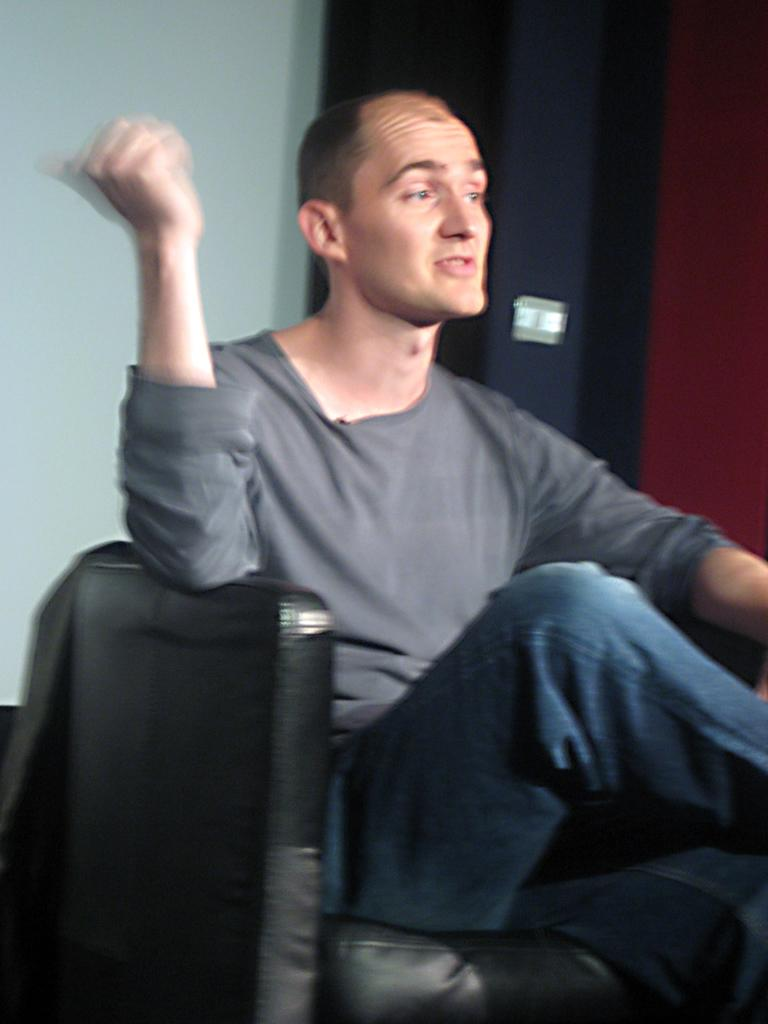What is the main subject of the image? There is a person in the image. What is the person doing in the image? The person is sitting on a chair. What can be seen behind the person? There is a wall behind the person. What type of orange is the person holding in the image? There is no orange present in the image. What is the size of the airplane in the image? There is no airplane present in the image. 